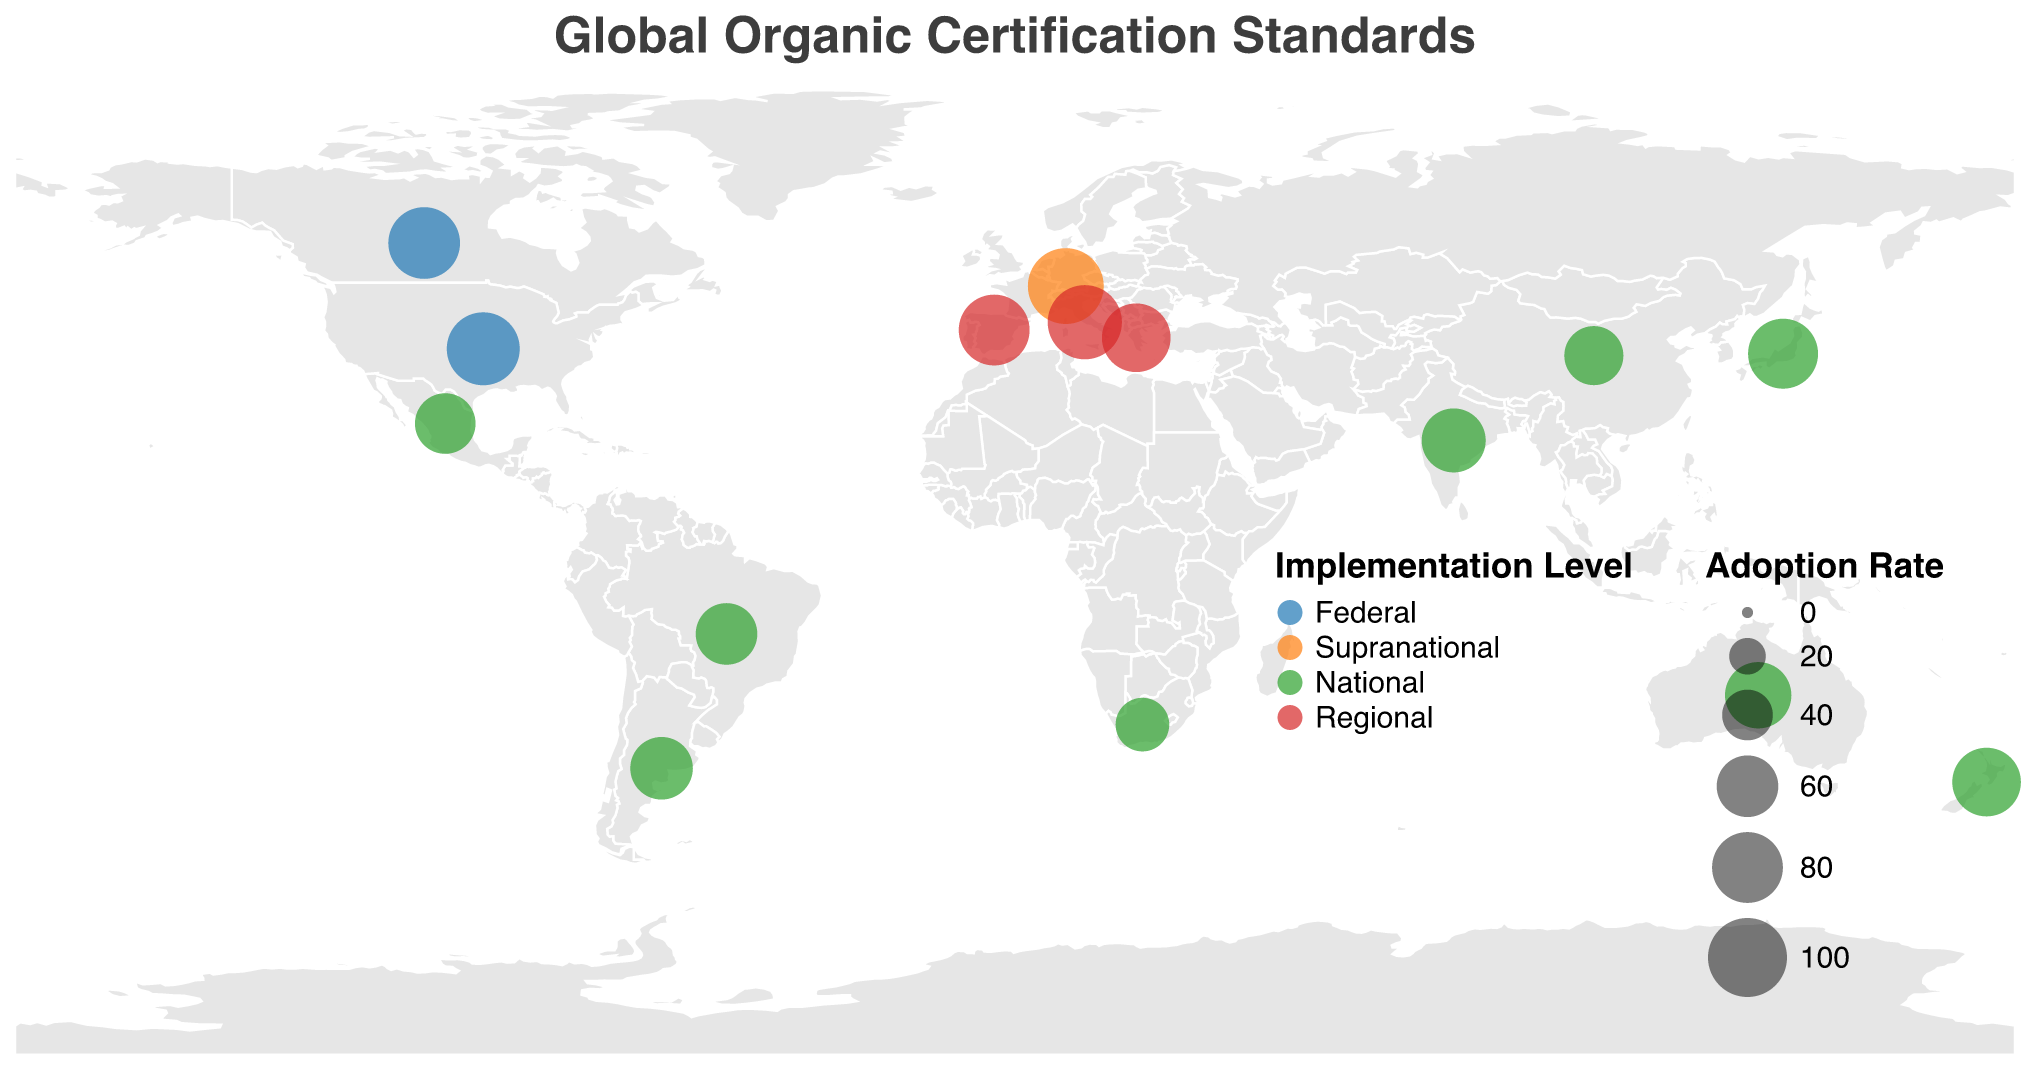What is the title of the plot? The title of the plot is displayed at the top of the figure. It reads "Global Organic Certification Standards".
Answer: Global Organic Certification Standards Which country has the highest adoption rate for organic certification standards? The country with the highest adoption rate can be identified by the size of the circles. The largest circle size corresponds to the highest adoption rate, which is the European Union with a rate of 92%.
Answer: European Union What is the implementation level of organic certification standards in South Africa? Implementation level can be identified by the color of the circles. South Africa is AFRISCO and is colored like other national-level implementations.
Answer: National Which region in the plot has both a supranational and a national certification standard implementation? By observing the colors and geographic locations, the European Union has both a supranational implementation (EU Organic) and national implementations in Italy, Spain, and Greece.
Answer: Europe What is the average adoption rate of countries with national-level certification standards? To compute the average adoption rate for national-level certifications, sum the adoption rates of all national-level standards and divide by the number of those countries. Adoption rates are 78, 70, 65, 60, 75, 55, 58, 45, 62, and 75. The total is 643, and there are 10 countries, so the average is 643/10.
Answer: 64.3 Which country has a federal implementation level with an 85% adoption rate? By looking at the colors representing federal implementation levels and the numbers, the United States has a federal implementation with an 85% adoption rate.
Answer: United States How does the adoption rate of China's organic certification standard compare to India's? Compare the adoption rate values directly. China's adoption rate is 55% and India's is 65%. Therefore, India's adoption rate is higher.
Answer: India has a higher adoption rate Identify the countries with regional-level implementation and specify their adoption rates. Regional-level implementations can be recognized by the red color. The countries with regional implementation are Italy (88%), Spain (80%), and Greece (75%).
Answer: Italy (88%), Spain (80%), Greece (75%) What is the sum of the adoption rates for federal-level implementations? Sum the adoption rates for federal implementation levels: the United States (85%) and Canada (82%). The total is 85 + 82.
Answer: 167 Which country has the lowest adoption rate for organic certification standards and what is that rate? By looking at the circle sizes and associated rates, the smallest circle represents South Africa with the lowest adoption rate of 45%.
Answer: South Africa, 45% 